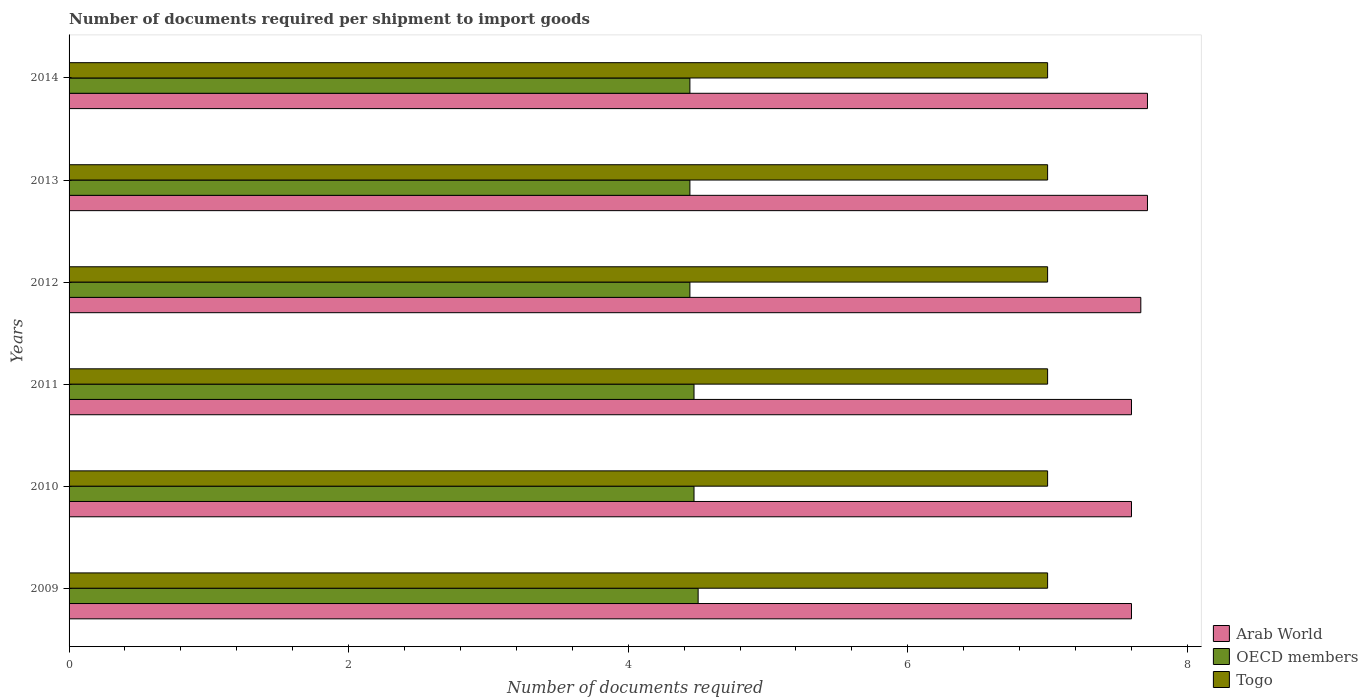Are the number of bars per tick equal to the number of legend labels?
Your answer should be very brief. Yes. Are the number of bars on each tick of the Y-axis equal?
Your response must be concise. Yes. How many bars are there on the 1st tick from the top?
Offer a very short reply. 3. What is the label of the 2nd group of bars from the top?
Make the answer very short. 2013. In how many cases, is the number of bars for a given year not equal to the number of legend labels?
Offer a very short reply. 0. What is the number of documents required per shipment to import goods in OECD members in 2010?
Make the answer very short. 4.47. Across all years, what is the maximum number of documents required per shipment to import goods in OECD members?
Your response must be concise. 4.5. Across all years, what is the minimum number of documents required per shipment to import goods in Arab World?
Provide a short and direct response. 7.6. In which year was the number of documents required per shipment to import goods in Arab World maximum?
Ensure brevity in your answer.  2013. What is the total number of documents required per shipment to import goods in Arab World in the graph?
Your answer should be very brief. 45.9. What is the difference between the number of documents required per shipment to import goods in Togo in 2014 and the number of documents required per shipment to import goods in Arab World in 2012?
Your answer should be very brief. -0.67. What is the average number of documents required per shipment to import goods in OECD members per year?
Offer a very short reply. 4.46. In the year 2010, what is the difference between the number of documents required per shipment to import goods in Togo and number of documents required per shipment to import goods in OECD members?
Keep it short and to the point. 2.53. What is the ratio of the number of documents required per shipment to import goods in OECD members in 2013 to that in 2014?
Offer a terse response. 1. What is the difference between the highest and the lowest number of documents required per shipment to import goods in OECD members?
Offer a terse response. 0.06. What does the 3rd bar from the top in 2010 represents?
Offer a terse response. Arab World. What does the 1st bar from the bottom in 2013 represents?
Keep it short and to the point. Arab World. Is it the case that in every year, the sum of the number of documents required per shipment to import goods in Togo and number of documents required per shipment to import goods in Arab World is greater than the number of documents required per shipment to import goods in OECD members?
Your answer should be compact. Yes. How many bars are there?
Offer a very short reply. 18. What is the difference between two consecutive major ticks on the X-axis?
Your answer should be very brief. 2. How are the legend labels stacked?
Your answer should be very brief. Vertical. What is the title of the graph?
Make the answer very short. Number of documents required per shipment to import goods. What is the label or title of the X-axis?
Give a very brief answer. Number of documents required. What is the label or title of the Y-axis?
Your answer should be compact. Years. What is the Number of documents required in Togo in 2009?
Your answer should be very brief. 7. What is the Number of documents required of Arab World in 2010?
Provide a succinct answer. 7.6. What is the Number of documents required in OECD members in 2010?
Offer a very short reply. 4.47. What is the Number of documents required of OECD members in 2011?
Provide a short and direct response. 4.47. What is the Number of documents required in Togo in 2011?
Offer a terse response. 7. What is the Number of documents required in Arab World in 2012?
Your answer should be very brief. 7.67. What is the Number of documents required in OECD members in 2012?
Provide a short and direct response. 4.44. What is the Number of documents required in Togo in 2012?
Your answer should be compact. 7. What is the Number of documents required in Arab World in 2013?
Ensure brevity in your answer.  7.71. What is the Number of documents required in OECD members in 2013?
Offer a terse response. 4.44. What is the Number of documents required of Togo in 2013?
Your response must be concise. 7. What is the Number of documents required in Arab World in 2014?
Ensure brevity in your answer.  7.71. What is the Number of documents required of OECD members in 2014?
Your response must be concise. 4.44. What is the Number of documents required in Togo in 2014?
Keep it short and to the point. 7. Across all years, what is the maximum Number of documents required of Arab World?
Offer a terse response. 7.71. Across all years, what is the maximum Number of documents required in OECD members?
Provide a succinct answer. 4.5. Across all years, what is the maximum Number of documents required in Togo?
Make the answer very short. 7. Across all years, what is the minimum Number of documents required of OECD members?
Provide a short and direct response. 4.44. Across all years, what is the minimum Number of documents required of Togo?
Offer a very short reply. 7. What is the total Number of documents required in Arab World in the graph?
Ensure brevity in your answer.  45.9. What is the total Number of documents required in OECD members in the graph?
Your answer should be compact. 26.76. What is the difference between the Number of documents required in Arab World in 2009 and that in 2010?
Ensure brevity in your answer.  0. What is the difference between the Number of documents required of OECD members in 2009 and that in 2010?
Keep it short and to the point. 0.03. What is the difference between the Number of documents required in Togo in 2009 and that in 2010?
Keep it short and to the point. 0. What is the difference between the Number of documents required of Arab World in 2009 and that in 2011?
Provide a short and direct response. 0. What is the difference between the Number of documents required in OECD members in 2009 and that in 2011?
Offer a terse response. 0.03. What is the difference between the Number of documents required of Togo in 2009 and that in 2011?
Your response must be concise. 0. What is the difference between the Number of documents required in Arab World in 2009 and that in 2012?
Your answer should be very brief. -0.07. What is the difference between the Number of documents required of OECD members in 2009 and that in 2012?
Your answer should be compact. 0.06. What is the difference between the Number of documents required of Togo in 2009 and that in 2012?
Your answer should be very brief. 0. What is the difference between the Number of documents required in Arab World in 2009 and that in 2013?
Offer a terse response. -0.11. What is the difference between the Number of documents required in OECD members in 2009 and that in 2013?
Offer a very short reply. 0.06. What is the difference between the Number of documents required in Togo in 2009 and that in 2013?
Provide a short and direct response. 0. What is the difference between the Number of documents required of Arab World in 2009 and that in 2014?
Offer a very short reply. -0.11. What is the difference between the Number of documents required in OECD members in 2009 and that in 2014?
Offer a very short reply. 0.06. What is the difference between the Number of documents required of Arab World in 2010 and that in 2011?
Offer a terse response. 0. What is the difference between the Number of documents required in OECD members in 2010 and that in 2011?
Your answer should be compact. 0. What is the difference between the Number of documents required in Arab World in 2010 and that in 2012?
Give a very brief answer. -0.07. What is the difference between the Number of documents required in OECD members in 2010 and that in 2012?
Keep it short and to the point. 0.03. What is the difference between the Number of documents required in Togo in 2010 and that in 2012?
Offer a terse response. 0. What is the difference between the Number of documents required in Arab World in 2010 and that in 2013?
Make the answer very short. -0.11. What is the difference between the Number of documents required of OECD members in 2010 and that in 2013?
Provide a short and direct response. 0.03. What is the difference between the Number of documents required in Arab World in 2010 and that in 2014?
Your answer should be very brief. -0.11. What is the difference between the Number of documents required in OECD members in 2010 and that in 2014?
Ensure brevity in your answer.  0.03. What is the difference between the Number of documents required in Togo in 2010 and that in 2014?
Your response must be concise. 0. What is the difference between the Number of documents required in Arab World in 2011 and that in 2012?
Give a very brief answer. -0.07. What is the difference between the Number of documents required of OECD members in 2011 and that in 2012?
Make the answer very short. 0.03. What is the difference between the Number of documents required in Arab World in 2011 and that in 2013?
Provide a succinct answer. -0.11. What is the difference between the Number of documents required of OECD members in 2011 and that in 2013?
Provide a succinct answer. 0.03. What is the difference between the Number of documents required in Arab World in 2011 and that in 2014?
Provide a short and direct response. -0.11. What is the difference between the Number of documents required of OECD members in 2011 and that in 2014?
Provide a short and direct response. 0.03. What is the difference between the Number of documents required of Togo in 2011 and that in 2014?
Give a very brief answer. 0. What is the difference between the Number of documents required of Arab World in 2012 and that in 2013?
Offer a terse response. -0.05. What is the difference between the Number of documents required in Togo in 2012 and that in 2013?
Offer a terse response. 0. What is the difference between the Number of documents required in Arab World in 2012 and that in 2014?
Give a very brief answer. -0.05. What is the difference between the Number of documents required in OECD members in 2012 and that in 2014?
Your response must be concise. 0. What is the difference between the Number of documents required of Togo in 2012 and that in 2014?
Give a very brief answer. 0. What is the difference between the Number of documents required in Arab World in 2009 and the Number of documents required in OECD members in 2010?
Provide a short and direct response. 3.13. What is the difference between the Number of documents required in Arab World in 2009 and the Number of documents required in Togo in 2010?
Make the answer very short. 0.6. What is the difference between the Number of documents required of Arab World in 2009 and the Number of documents required of OECD members in 2011?
Your response must be concise. 3.13. What is the difference between the Number of documents required of Arab World in 2009 and the Number of documents required of Togo in 2011?
Make the answer very short. 0.6. What is the difference between the Number of documents required in OECD members in 2009 and the Number of documents required in Togo in 2011?
Provide a short and direct response. -2.5. What is the difference between the Number of documents required of Arab World in 2009 and the Number of documents required of OECD members in 2012?
Offer a very short reply. 3.16. What is the difference between the Number of documents required of OECD members in 2009 and the Number of documents required of Togo in 2012?
Your answer should be compact. -2.5. What is the difference between the Number of documents required of Arab World in 2009 and the Number of documents required of OECD members in 2013?
Offer a terse response. 3.16. What is the difference between the Number of documents required in Arab World in 2009 and the Number of documents required in OECD members in 2014?
Offer a terse response. 3.16. What is the difference between the Number of documents required in Arab World in 2009 and the Number of documents required in Togo in 2014?
Provide a short and direct response. 0.6. What is the difference between the Number of documents required of OECD members in 2009 and the Number of documents required of Togo in 2014?
Your response must be concise. -2.5. What is the difference between the Number of documents required of Arab World in 2010 and the Number of documents required of OECD members in 2011?
Your response must be concise. 3.13. What is the difference between the Number of documents required of Arab World in 2010 and the Number of documents required of Togo in 2011?
Provide a succinct answer. 0.6. What is the difference between the Number of documents required in OECD members in 2010 and the Number of documents required in Togo in 2011?
Your answer should be very brief. -2.53. What is the difference between the Number of documents required of Arab World in 2010 and the Number of documents required of OECD members in 2012?
Your response must be concise. 3.16. What is the difference between the Number of documents required in Arab World in 2010 and the Number of documents required in Togo in 2012?
Keep it short and to the point. 0.6. What is the difference between the Number of documents required of OECD members in 2010 and the Number of documents required of Togo in 2012?
Provide a succinct answer. -2.53. What is the difference between the Number of documents required in Arab World in 2010 and the Number of documents required in OECD members in 2013?
Your answer should be very brief. 3.16. What is the difference between the Number of documents required of Arab World in 2010 and the Number of documents required of Togo in 2013?
Offer a very short reply. 0.6. What is the difference between the Number of documents required of OECD members in 2010 and the Number of documents required of Togo in 2013?
Make the answer very short. -2.53. What is the difference between the Number of documents required in Arab World in 2010 and the Number of documents required in OECD members in 2014?
Your answer should be compact. 3.16. What is the difference between the Number of documents required in Arab World in 2010 and the Number of documents required in Togo in 2014?
Give a very brief answer. 0.6. What is the difference between the Number of documents required of OECD members in 2010 and the Number of documents required of Togo in 2014?
Provide a succinct answer. -2.53. What is the difference between the Number of documents required in Arab World in 2011 and the Number of documents required in OECD members in 2012?
Your response must be concise. 3.16. What is the difference between the Number of documents required in Arab World in 2011 and the Number of documents required in Togo in 2012?
Ensure brevity in your answer.  0.6. What is the difference between the Number of documents required of OECD members in 2011 and the Number of documents required of Togo in 2012?
Your response must be concise. -2.53. What is the difference between the Number of documents required of Arab World in 2011 and the Number of documents required of OECD members in 2013?
Give a very brief answer. 3.16. What is the difference between the Number of documents required of Arab World in 2011 and the Number of documents required of Togo in 2013?
Your answer should be compact. 0.6. What is the difference between the Number of documents required in OECD members in 2011 and the Number of documents required in Togo in 2013?
Your response must be concise. -2.53. What is the difference between the Number of documents required in Arab World in 2011 and the Number of documents required in OECD members in 2014?
Your answer should be very brief. 3.16. What is the difference between the Number of documents required of OECD members in 2011 and the Number of documents required of Togo in 2014?
Your response must be concise. -2.53. What is the difference between the Number of documents required in Arab World in 2012 and the Number of documents required in OECD members in 2013?
Offer a terse response. 3.23. What is the difference between the Number of documents required of Arab World in 2012 and the Number of documents required of Togo in 2013?
Make the answer very short. 0.67. What is the difference between the Number of documents required of OECD members in 2012 and the Number of documents required of Togo in 2013?
Your answer should be compact. -2.56. What is the difference between the Number of documents required in Arab World in 2012 and the Number of documents required in OECD members in 2014?
Offer a very short reply. 3.23. What is the difference between the Number of documents required in Arab World in 2012 and the Number of documents required in Togo in 2014?
Provide a succinct answer. 0.67. What is the difference between the Number of documents required in OECD members in 2012 and the Number of documents required in Togo in 2014?
Your response must be concise. -2.56. What is the difference between the Number of documents required of Arab World in 2013 and the Number of documents required of OECD members in 2014?
Provide a succinct answer. 3.27. What is the difference between the Number of documents required in OECD members in 2013 and the Number of documents required in Togo in 2014?
Ensure brevity in your answer.  -2.56. What is the average Number of documents required of Arab World per year?
Provide a short and direct response. 7.65. What is the average Number of documents required of OECD members per year?
Your answer should be compact. 4.46. In the year 2009, what is the difference between the Number of documents required in Arab World and Number of documents required in OECD members?
Your response must be concise. 3.1. In the year 2009, what is the difference between the Number of documents required in Arab World and Number of documents required in Togo?
Offer a terse response. 0.6. In the year 2010, what is the difference between the Number of documents required in Arab World and Number of documents required in OECD members?
Your answer should be very brief. 3.13. In the year 2010, what is the difference between the Number of documents required in OECD members and Number of documents required in Togo?
Provide a succinct answer. -2.53. In the year 2011, what is the difference between the Number of documents required of Arab World and Number of documents required of OECD members?
Ensure brevity in your answer.  3.13. In the year 2011, what is the difference between the Number of documents required of OECD members and Number of documents required of Togo?
Your answer should be very brief. -2.53. In the year 2012, what is the difference between the Number of documents required of Arab World and Number of documents required of OECD members?
Provide a succinct answer. 3.23. In the year 2012, what is the difference between the Number of documents required in OECD members and Number of documents required in Togo?
Your answer should be very brief. -2.56. In the year 2013, what is the difference between the Number of documents required in Arab World and Number of documents required in OECD members?
Provide a succinct answer. 3.27. In the year 2013, what is the difference between the Number of documents required in Arab World and Number of documents required in Togo?
Offer a very short reply. 0.71. In the year 2013, what is the difference between the Number of documents required in OECD members and Number of documents required in Togo?
Offer a very short reply. -2.56. In the year 2014, what is the difference between the Number of documents required of Arab World and Number of documents required of OECD members?
Ensure brevity in your answer.  3.27. In the year 2014, what is the difference between the Number of documents required in Arab World and Number of documents required in Togo?
Offer a terse response. 0.71. In the year 2014, what is the difference between the Number of documents required of OECD members and Number of documents required of Togo?
Give a very brief answer. -2.56. What is the ratio of the Number of documents required of Arab World in 2009 to that in 2010?
Your response must be concise. 1. What is the ratio of the Number of documents required in OECD members in 2009 to that in 2010?
Offer a terse response. 1.01. What is the ratio of the Number of documents required in OECD members in 2009 to that in 2011?
Your response must be concise. 1.01. What is the ratio of the Number of documents required in Arab World in 2009 to that in 2012?
Ensure brevity in your answer.  0.99. What is the ratio of the Number of documents required of OECD members in 2009 to that in 2012?
Ensure brevity in your answer.  1.01. What is the ratio of the Number of documents required of Arab World in 2009 to that in 2013?
Offer a very short reply. 0.99. What is the ratio of the Number of documents required of OECD members in 2009 to that in 2013?
Your response must be concise. 1.01. What is the ratio of the Number of documents required in Arab World in 2009 to that in 2014?
Make the answer very short. 0.99. What is the ratio of the Number of documents required of OECD members in 2009 to that in 2014?
Keep it short and to the point. 1.01. What is the ratio of the Number of documents required in Togo in 2009 to that in 2014?
Keep it short and to the point. 1. What is the ratio of the Number of documents required of Arab World in 2010 to that in 2011?
Your response must be concise. 1. What is the ratio of the Number of documents required in Togo in 2010 to that in 2011?
Offer a terse response. 1. What is the ratio of the Number of documents required of Arab World in 2010 to that in 2012?
Offer a very short reply. 0.99. What is the ratio of the Number of documents required in OECD members in 2010 to that in 2012?
Offer a terse response. 1.01. What is the ratio of the Number of documents required in Togo in 2010 to that in 2012?
Give a very brief answer. 1. What is the ratio of the Number of documents required of Arab World in 2010 to that in 2013?
Keep it short and to the point. 0.99. What is the ratio of the Number of documents required of OECD members in 2010 to that in 2013?
Offer a terse response. 1.01. What is the ratio of the Number of documents required in Togo in 2010 to that in 2013?
Offer a very short reply. 1. What is the ratio of the Number of documents required of Arab World in 2010 to that in 2014?
Ensure brevity in your answer.  0.99. What is the ratio of the Number of documents required in OECD members in 2010 to that in 2014?
Ensure brevity in your answer.  1.01. What is the ratio of the Number of documents required of OECD members in 2011 to that in 2012?
Offer a terse response. 1.01. What is the ratio of the Number of documents required in Arab World in 2011 to that in 2013?
Provide a short and direct response. 0.99. What is the ratio of the Number of documents required of OECD members in 2011 to that in 2013?
Keep it short and to the point. 1.01. What is the ratio of the Number of documents required of Arab World in 2011 to that in 2014?
Provide a succinct answer. 0.99. What is the ratio of the Number of documents required in OECD members in 2011 to that in 2014?
Your answer should be very brief. 1.01. What is the ratio of the Number of documents required in Arab World in 2012 to that in 2014?
Keep it short and to the point. 0.99. What is the ratio of the Number of documents required in Arab World in 2013 to that in 2014?
Provide a succinct answer. 1. What is the ratio of the Number of documents required of Togo in 2013 to that in 2014?
Give a very brief answer. 1. What is the difference between the highest and the second highest Number of documents required of Arab World?
Offer a very short reply. 0. What is the difference between the highest and the second highest Number of documents required of OECD members?
Make the answer very short. 0.03. What is the difference between the highest and the second highest Number of documents required of Togo?
Provide a short and direct response. 0. What is the difference between the highest and the lowest Number of documents required of Arab World?
Offer a very short reply. 0.11. What is the difference between the highest and the lowest Number of documents required in OECD members?
Keep it short and to the point. 0.06. What is the difference between the highest and the lowest Number of documents required in Togo?
Your response must be concise. 0. 